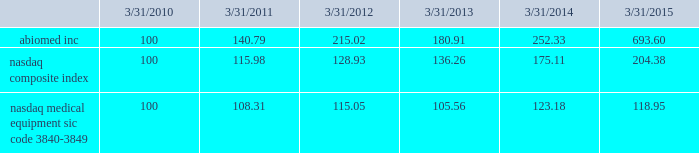Performance graph the following graph compares the yearly change in the cumulative total stockholder return for our last five full fiscal years , based upon the market price of our common stock , with the cumulative total return on a nasdaq composite index ( u.s .
Companies ) and a peer group , the nasdaq medical equipment-sic code 3840-3849 index , which is comprised of medical equipment companies , for that period .
The performance graph assumes the investment of $ 100 on march 31 , 2010 in our common stock , the nasdaq composite index ( u.s .
Companies ) and the peer group index , and the reinvestment of any and all dividends. .
This graph is not 201csoliciting material 201d under regulation 14a or 14c of the rules promulgated under the securities exchange act of 1934 , is not deemed filed with the securities and exchange commission and is not to be incorporated by reference in any of our filings under the securities act of 1933 , as amended , or the exchange act whether made before or after the date hereof and irrespective of any general incorporation language in any such filing .
Transfer agent american stock transfer & trust company , 59 maiden lane , new york , ny 10038 , is our stock transfer agent. .
What is the roi of an investment in nasdaq composite index from march 2010 to march 2013? 
Computations: ((136.26 - 100) / 100)
Answer: 0.3626. 